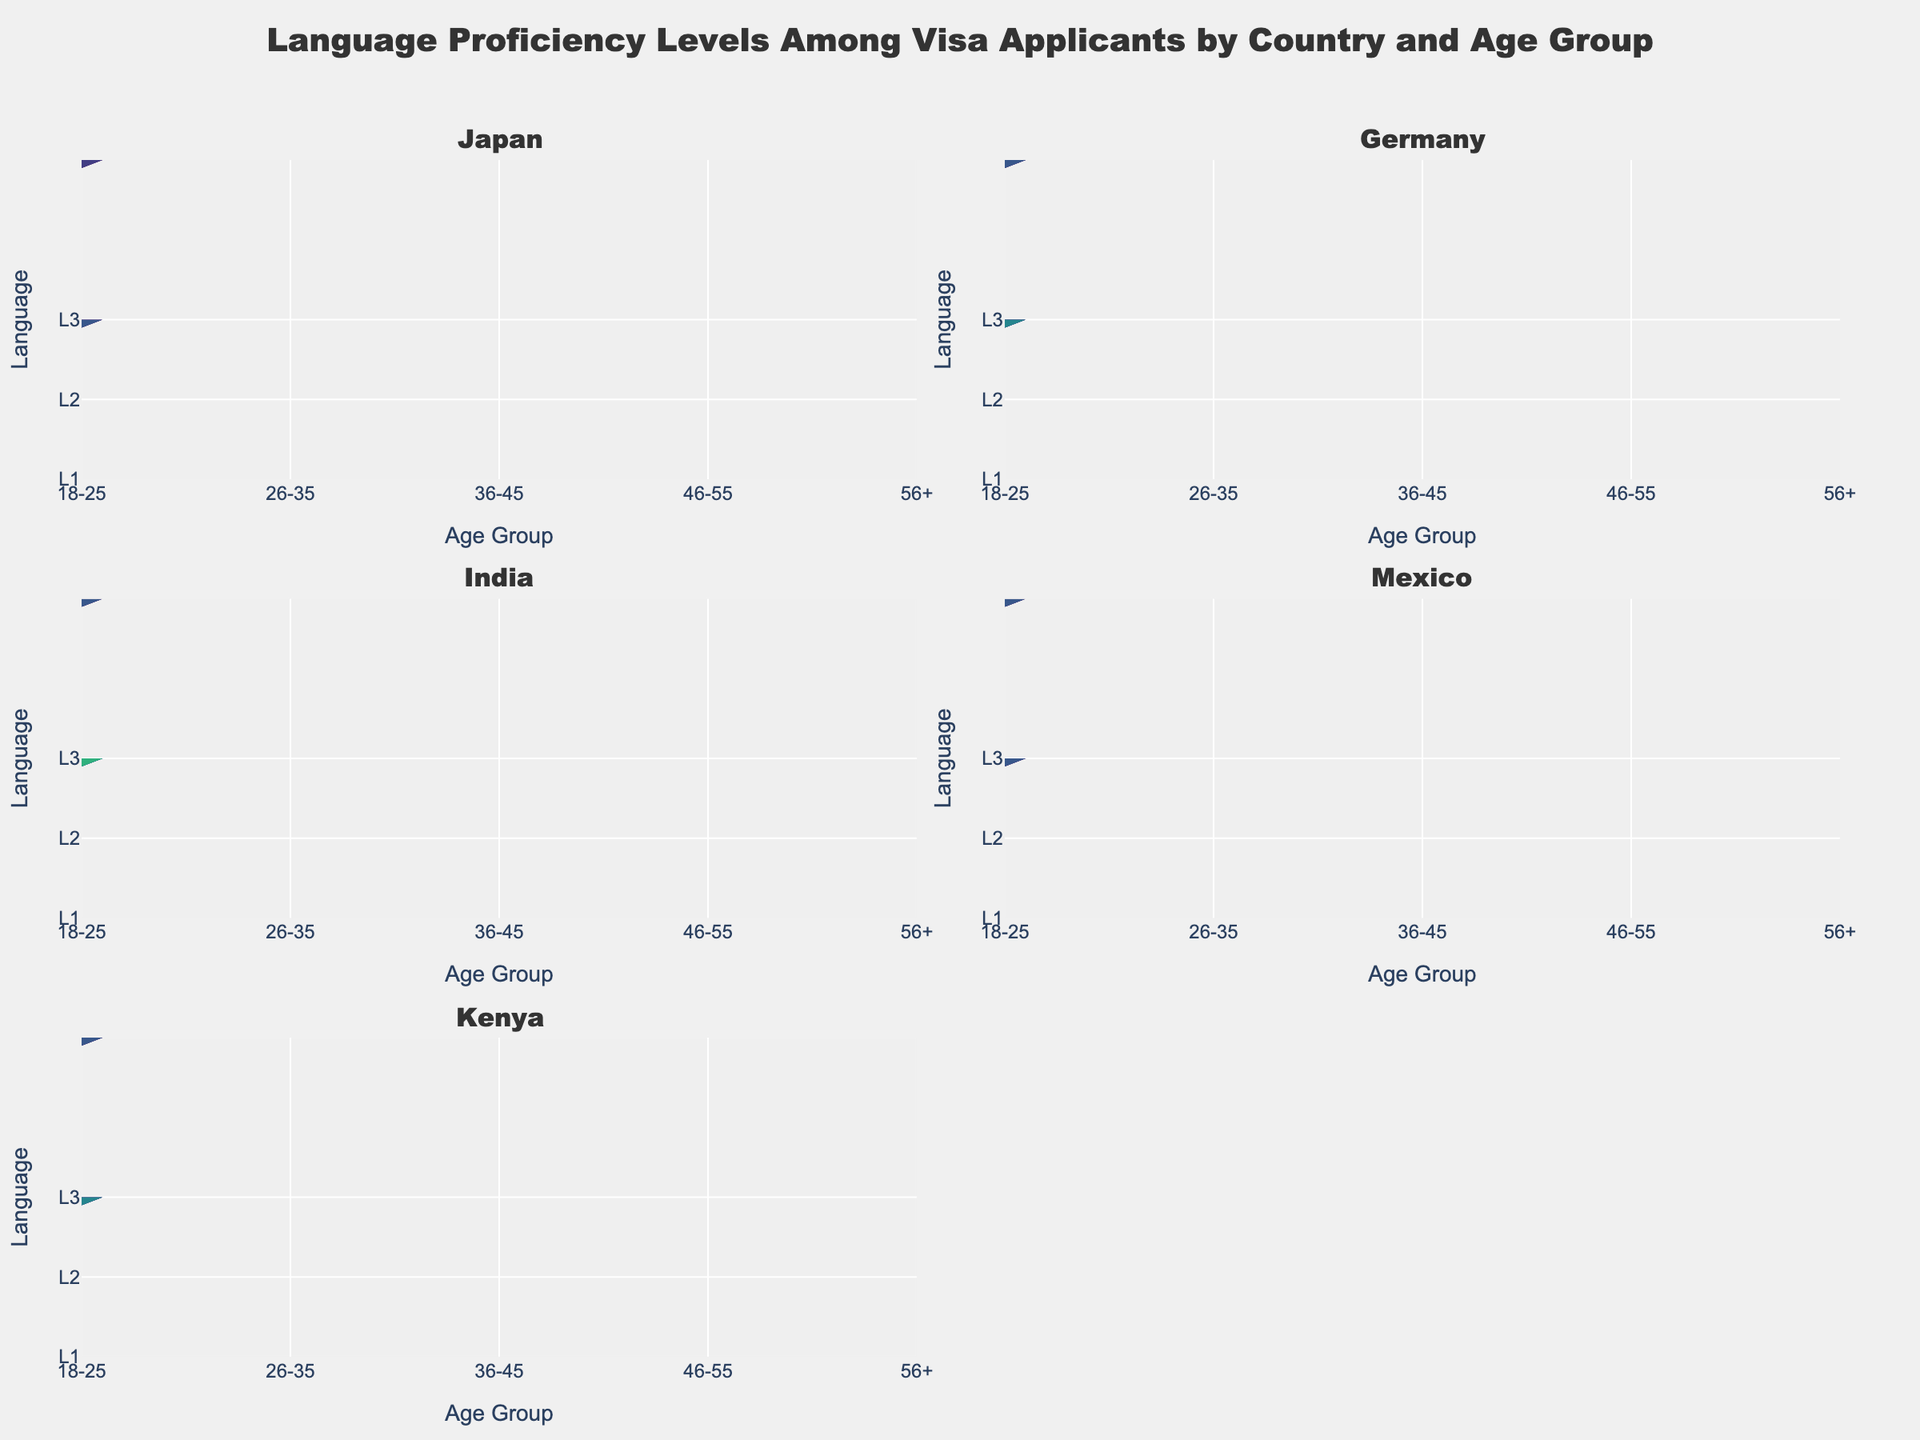Which country in the plot shows the highest proficiency in L1 for the age group 18-25? To find the highest proficiency in L1 for the age group 18-25, look at the L1 contour plots for each country at the age group 18-25. The country with the highest L1 proficiency will have the highest value. According to the data, Germany has the highest L1 proficiency of 0.9.
Answer: Germany How does the L3 proficiency level change for Japanese applicants as they age? Look at the L3 contour plots for Japan across different age groups. The proficiency starts at 0.1 for 18-25, increases to 0.2 for 26-35, 0.25 for 36-45, peaks at 0.4 during 46-55, and then drops to 0.3 for 56+. This indicates a general increase until a decline for the oldest age group.
Answer: Peaks at 46-55, then decreases Compare the L2 proficiency levels of Indian and Kenyan applicants in the age group 36-45. Which one shows higher proficiency? Check the L2 contour plots for both India and Kenya in the age group 36-45. India's proficiency level in L2 is 0.5, while Kenya's is 0.4. Therefore, Indian applicants show higher proficiency in L2 for this age group.
Answer: India Which country has the most significant decline in L1 proficiency as applicants age from 18-25 to 56+? Compare the L1 proficiency levels from age group 18-25 to age group 56+ for each country. Find the difference for each country: Japan (0.8 to 0.4, decrease of 0.4), Germany (0.9 to 0.6, decrease of 0.3), India (0.6 to 0.3, decrease of 0.3), Mexico (0.75 to 0.55, decrease of 0.2), Kenya (0.7 to 0.5, decrease of 0.2). Thus, Japan shows the most significant decline.
Answer: Japan In the age group 46-55, which language proficiency is the highest for Mexican applicants? Check the contour plots for Mexico in the age group 46-55. Compare the proficiency levels for L1 (0.6), L2 (0.35), and L3 (0.25). The highest proficiency level is for L1 at 0.6.
Answer: L1 Which country shows the least variability in L3 proficiency across all age groups? For each country, observe the differences between L3 proficiency levels across age groups. Japan's levels range from 0.1 to 0.4, Germany’s from 0.2 to 0.4, India’s from 0.2 to 0.4, Mexico’s from 0.2 to 0.3, and Kenya’s from 0.2 to 0.3. Mexico and Kenya show the least variability, both ranging from 0.2 to 0.3.
Answer: Mexico or Kenya 